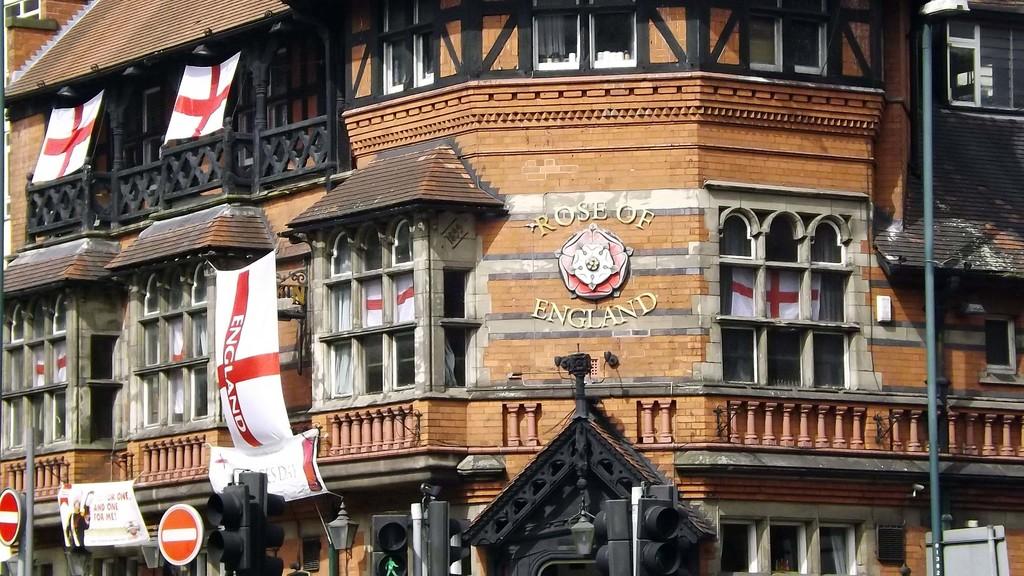What is on the flag?
Offer a very short reply. England. What is the name of the store?
Your response must be concise. Rose of england. 